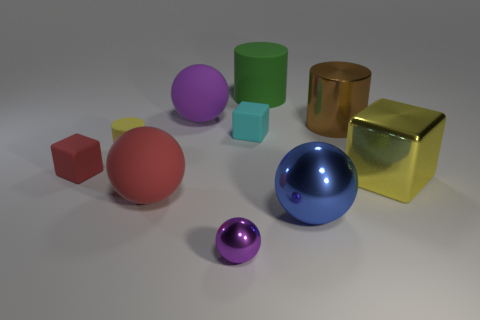Subtract all red balls. How many balls are left? 3 Subtract 2 balls. How many balls are left? 2 Subtract all blue shiny spheres. How many spheres are left? 3 Subtract all gray spheres. Subtract all brown blocks. How many spheres are left? 4 Subtract all spheres. How many objects are left? 6 Add 4 tiny blue rubber balls. How many tiny blue rubber balls exist? 4 Subtract 0 gray balls. How many objects are left? 10 Subtract all matte cylinders. Subtract all small rubber blocks. How many objects are left? 6 Add 9 green matte things. How many green matte things are left? 10 